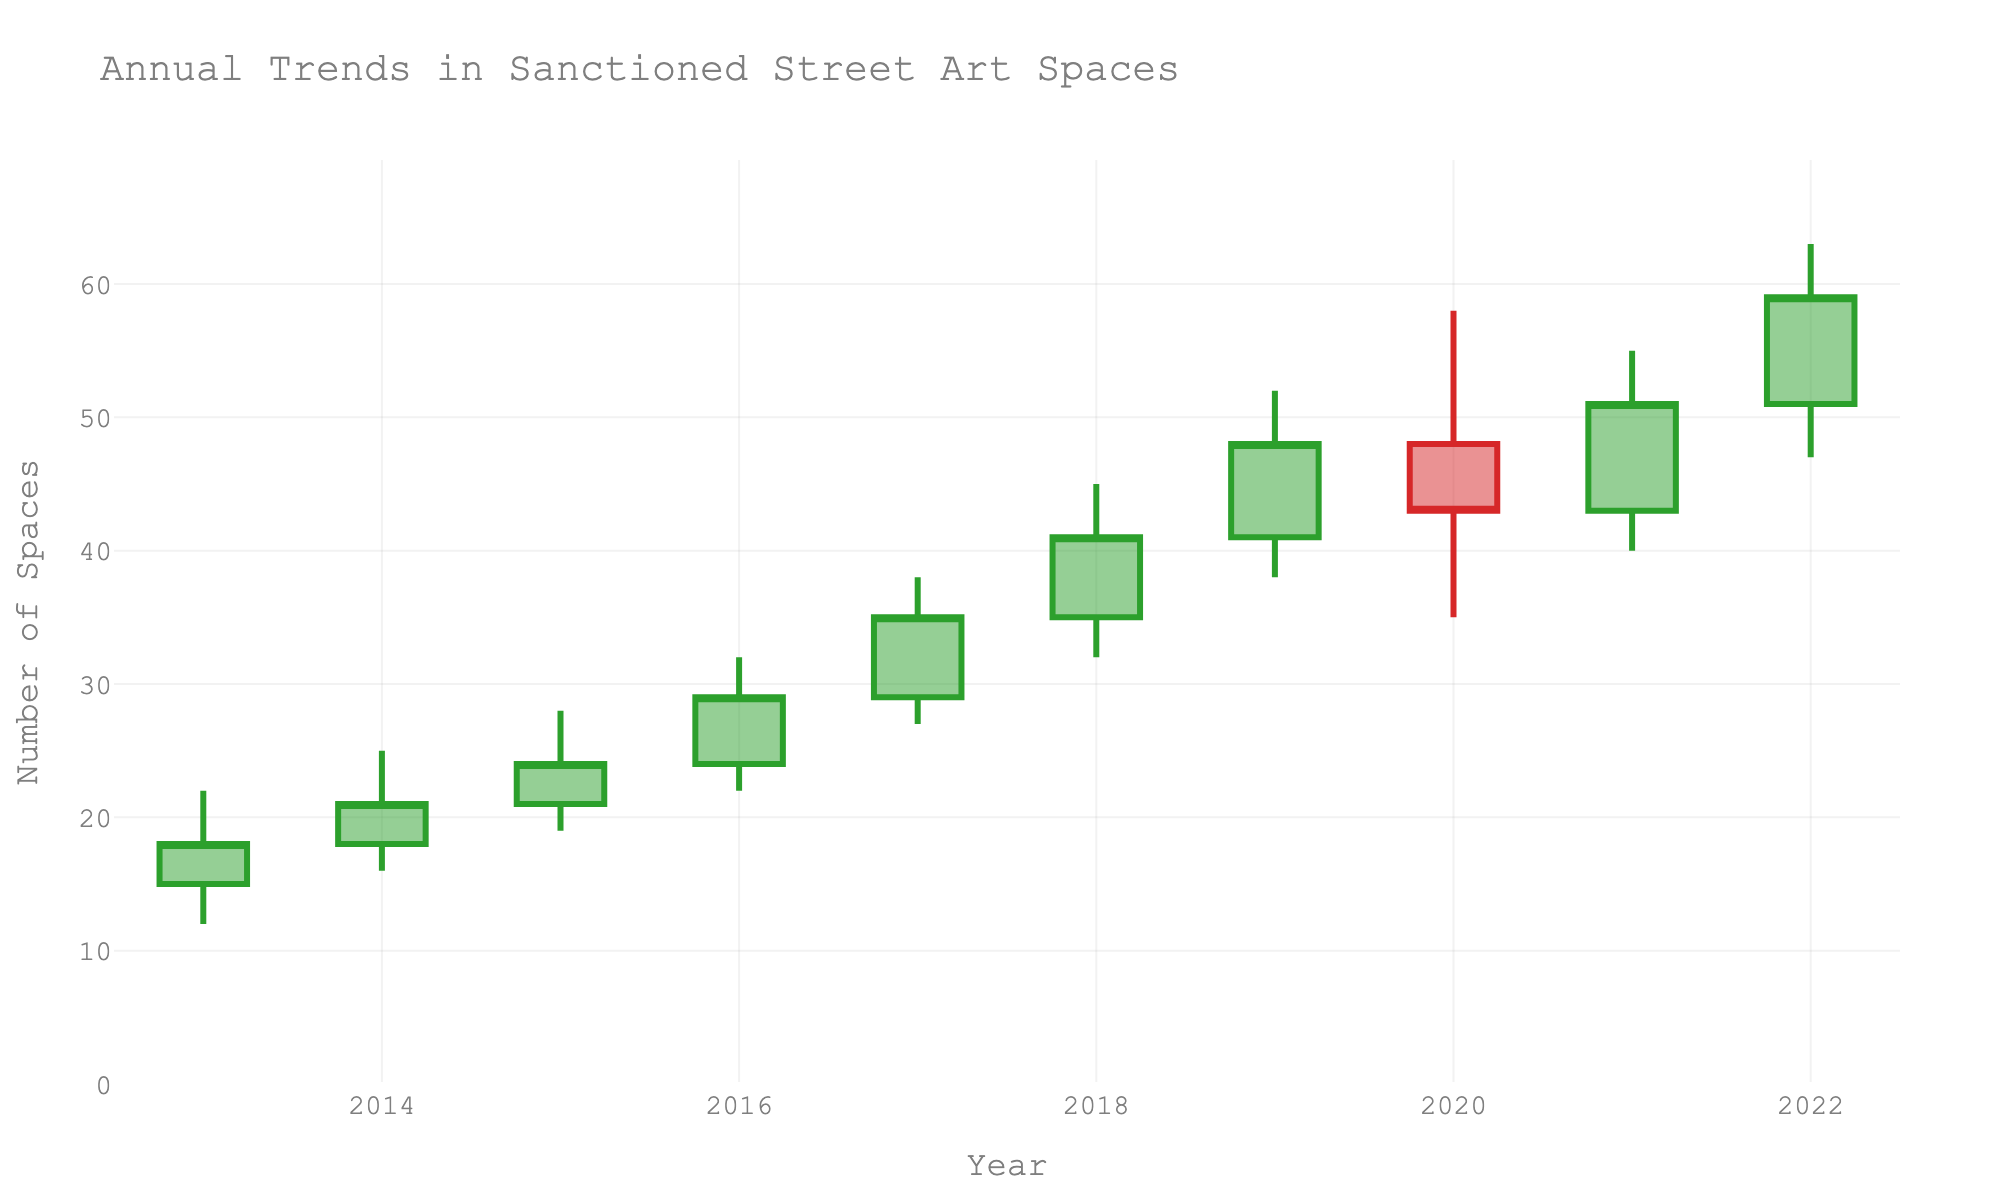What is the title of the figure? The title is typically positioned at the top of the figure. Here it is written as 'Annual Trends in Sanctioned Street Art Spaces'.
Answer: Annual Trends in Sanctioned Street Art Spaces What is the highest number of sanctioned street art spaces in any given year? The highest number corresponds to the highest value of the 'High' data series. By glancing at the chart, it's highest in 2022, at 63.
Answer: 63 In what year did the number of sanctioned spaces close at its peak? The peak closing value can be identified by looking at the 'Close' values. In 2022, the close value is at its peak, which is 59.
Answer: 2022 How many years show an increasing trend in the number of sanctioned spaces based on closing values? An increasing trend can be seen when each successive year's close value is greater than the previous year's close. Inspecting the figure from 2013 to 2022 shows a general upward trend with only 2020 breaking it.
Answer: 8 years Which year showed the largest difference between its highest and lowest number of spaces? To determine this, consider the difference between the 'High' and 'Low' values of each year. The year 2022, with a range of 63 - 47 = 16, stands out.
Answer: 2022 How did the sanctioned spaces trend from 2019 to 2020? Compare the values from 2019 and 2020. The closing value from 48 in 2019 decreases to 43 in 2020, indicating a downward trend.
Answer: Downward In which year(s) did the number of sanctioned spaces never fall below the opening value of the previous year? Compare each year's low with the previous year's open value. From 2015 to 2022, each year's low is higher than the previous year's open, except for 2020 which dips below 2019's open.
Answer: 2015-2019, 2021-2022 Which years had their closing values higher than the opening value of the following year? Scan the years and check if the closing value is greater than the subsequent year's opening. No years meet this criterion, as all the close values are either equal or less than the next year's open.
Answer: None Was there any year where the number of spaces did not change from open to close values? Look for years where the 'Open' and 'Close' values are equal. None of the years show identical open and close values.
Answer: No 